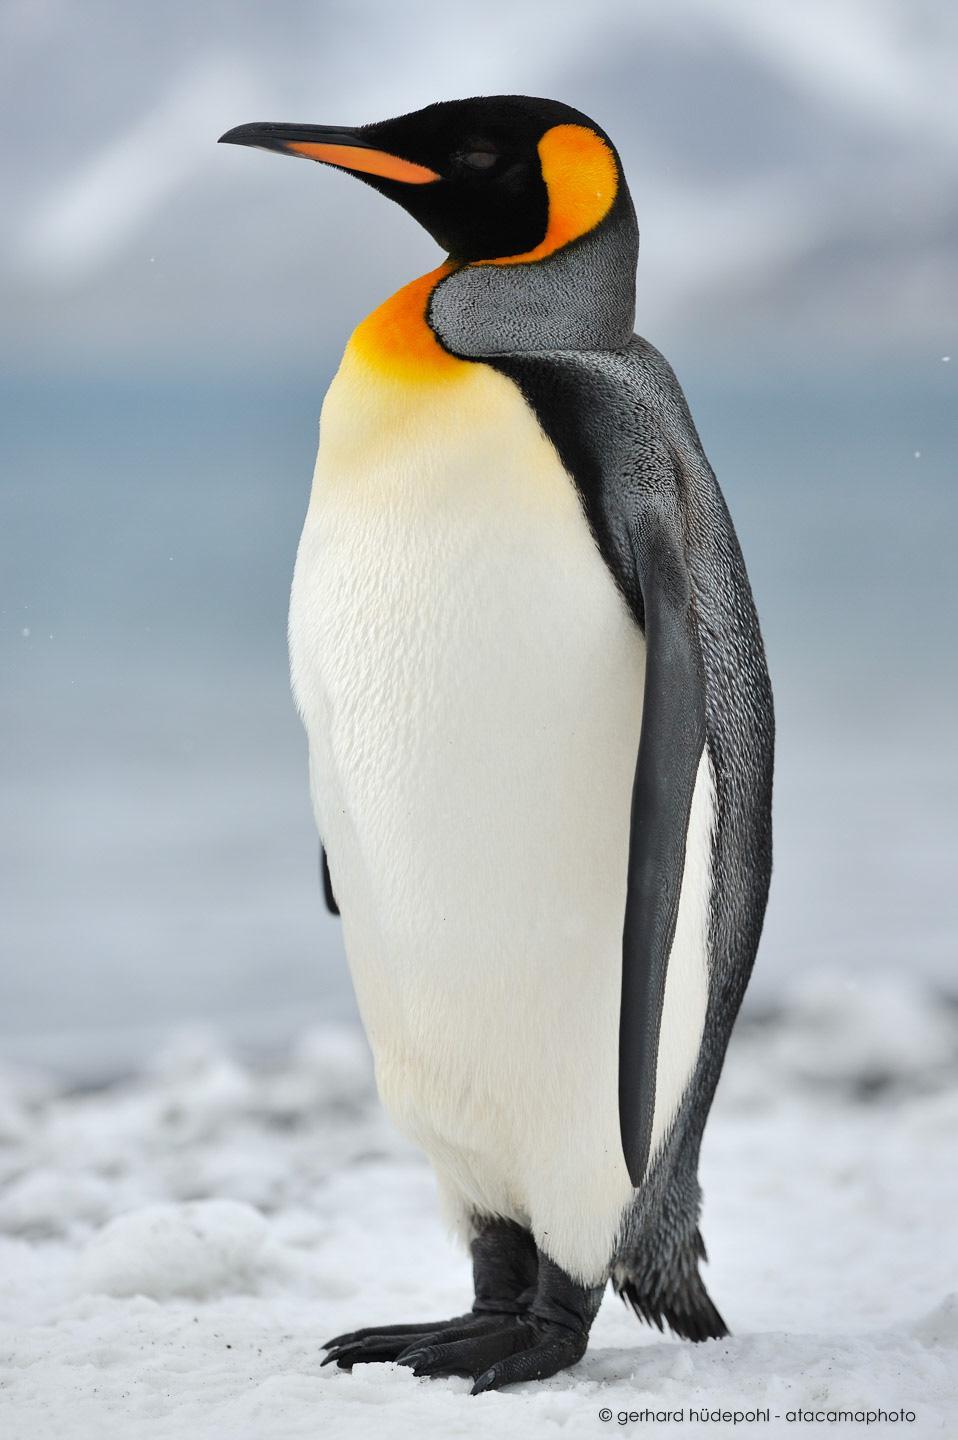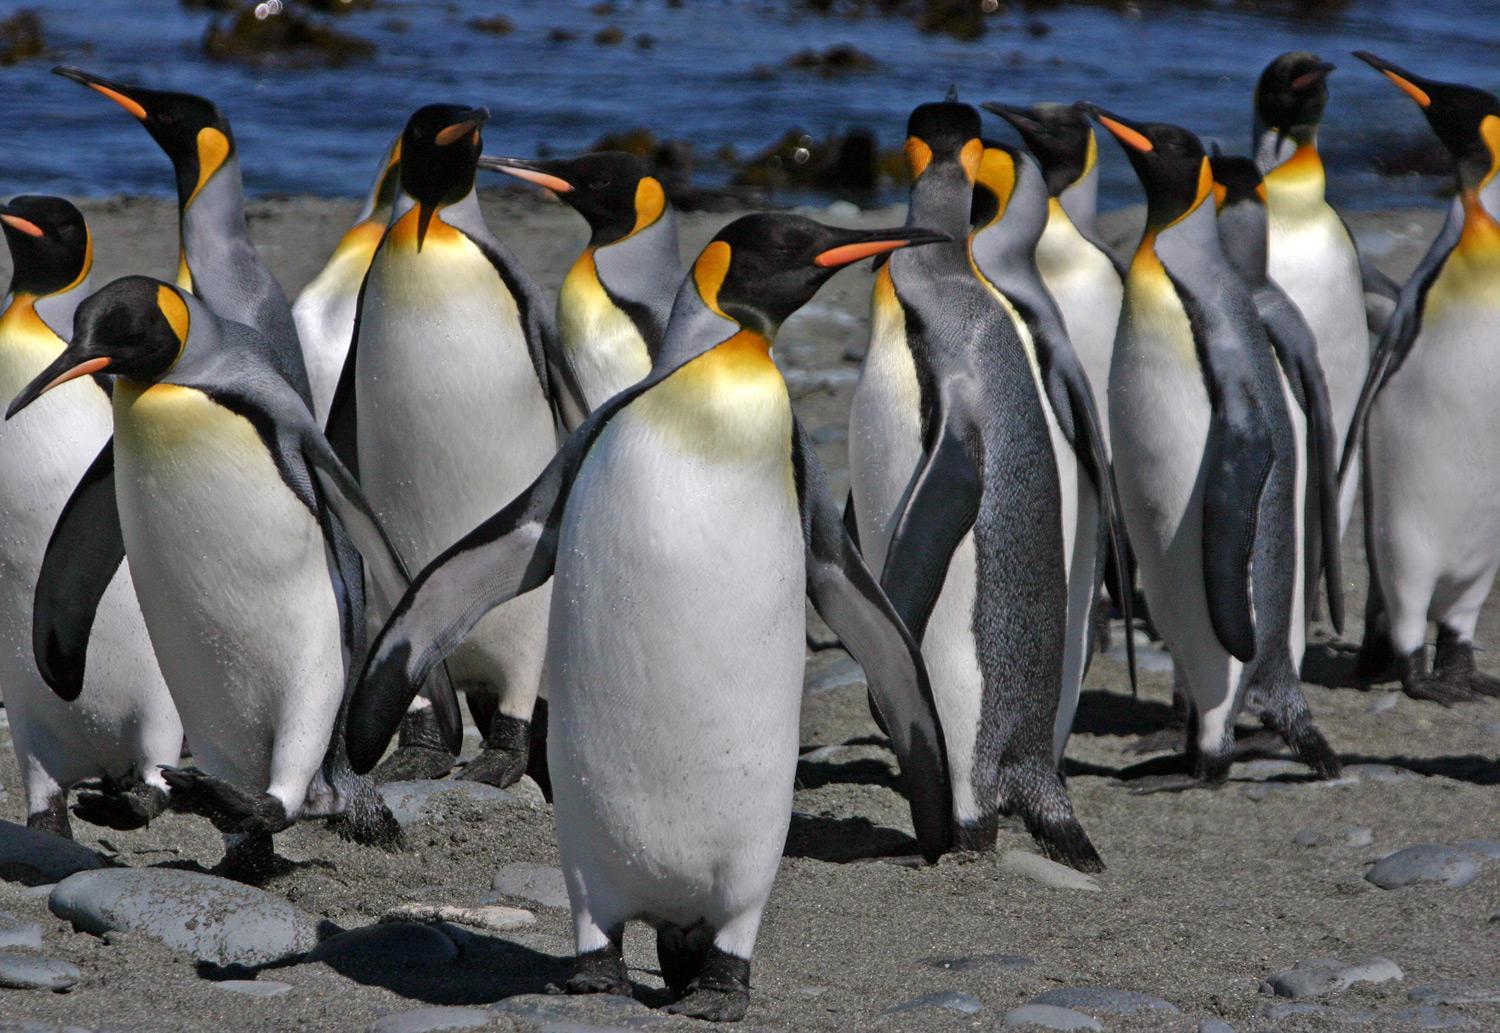The first image is the image on the left, the second image is the image on the right. Considering the images on both sides, is "One image contains just one penguin." valid? Answer yes or no. Yes. The first image is the image on the left, the second image is the image on the right. Given the left and right images, does the statement "There are five penguins" hold true? Answer yes or no. No. 